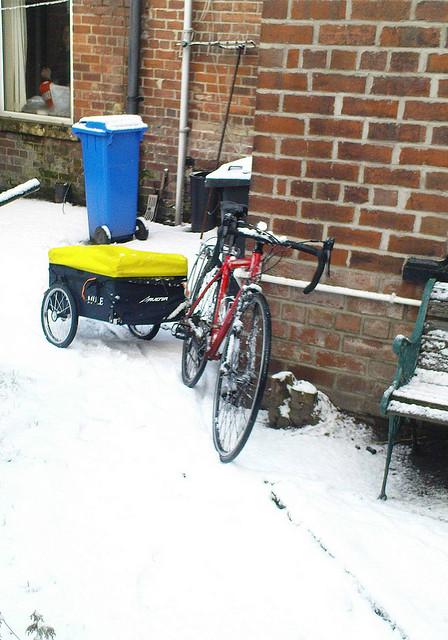What's the blue plastic container?
Write a very short answer. Trash can. What's attached to the bike?
Keep it brief. Wagon. What kind of bike is in the picture?
Give a very brief answer. Bicycle. What color is the bench?
Write a very short answer. Green. Is it warm?
Concise answer only. No. 